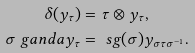<formula> <loc_0><loc_0><loc_500><loc_500>\delta ( y _ { \tau } ) & = \tau \otimes y _ { \tau } , \\ \sigma \ g a n d a y _ { \tau } & = \ s g ( \sigma ) y _ { \sigma \tau \sigma ^ { - 1 } } .</formula> 